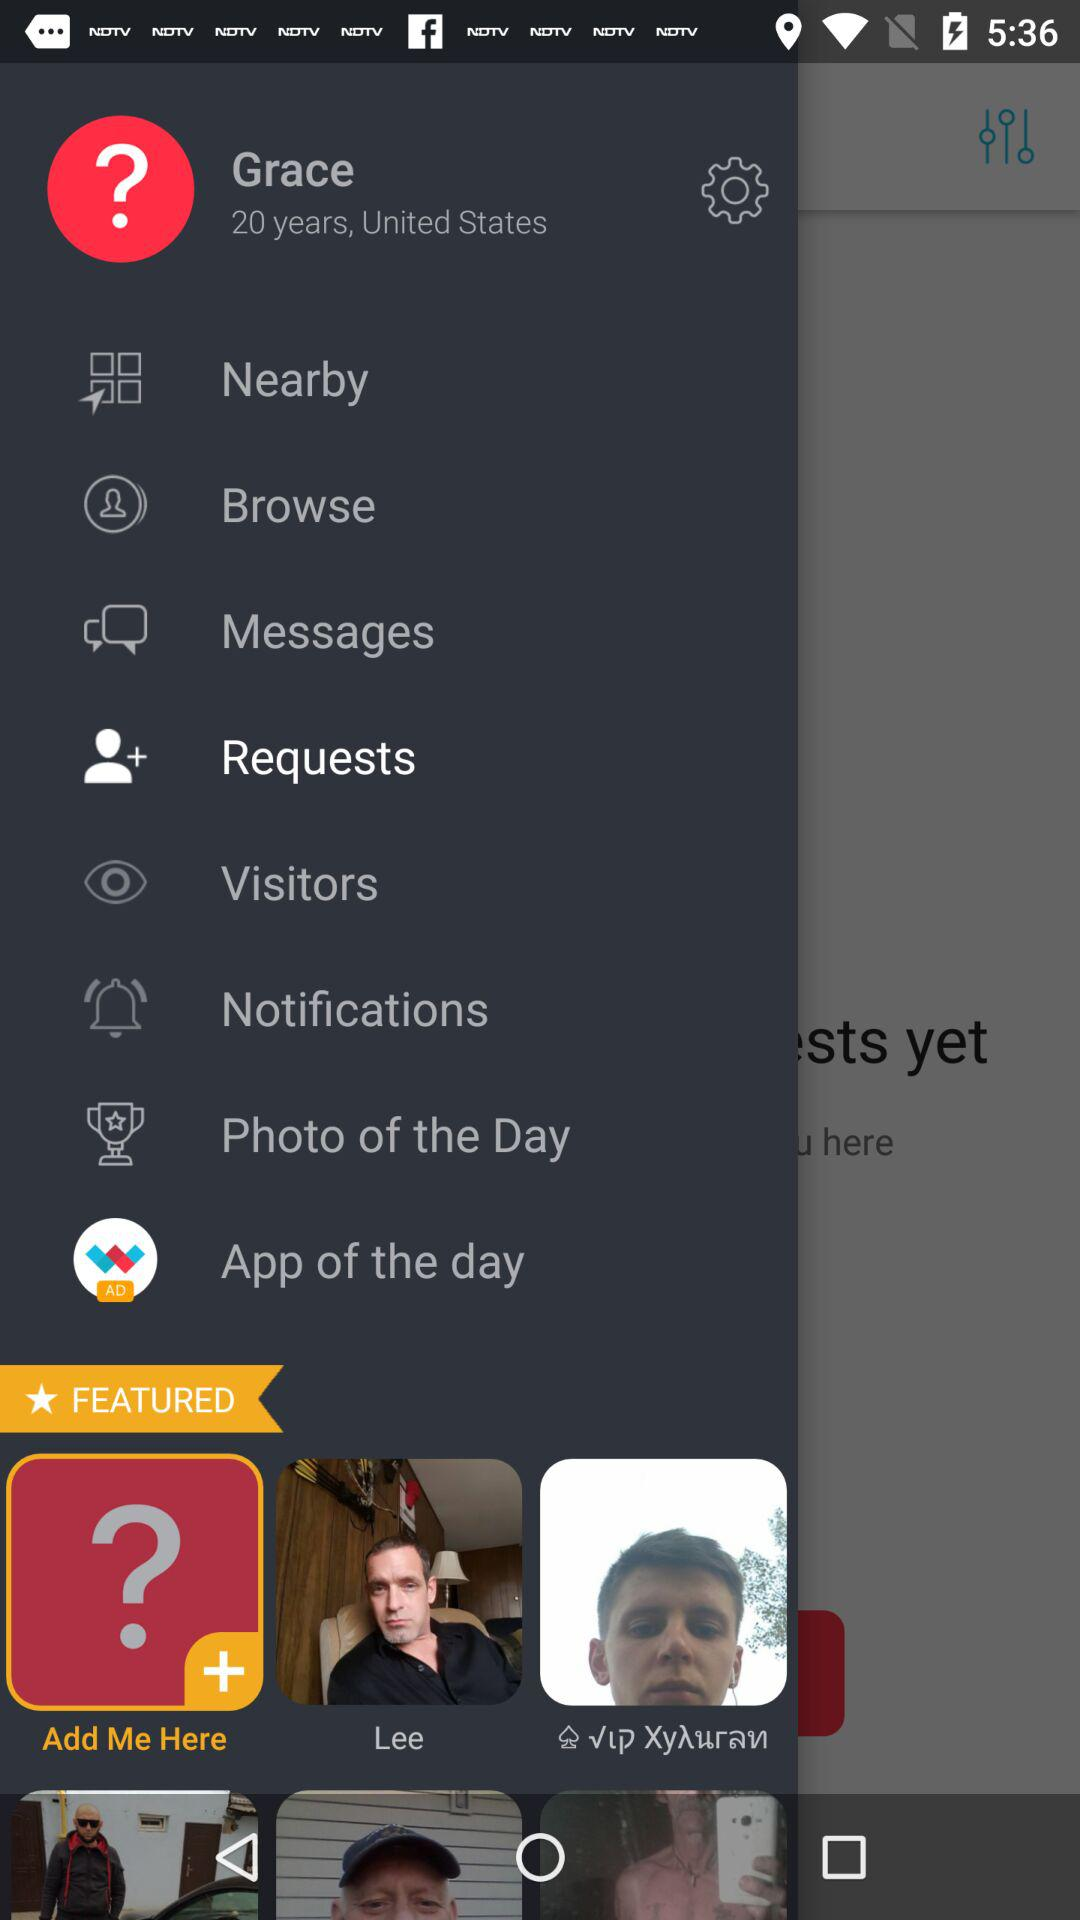What is the age of the person? The person is 20 years old. 